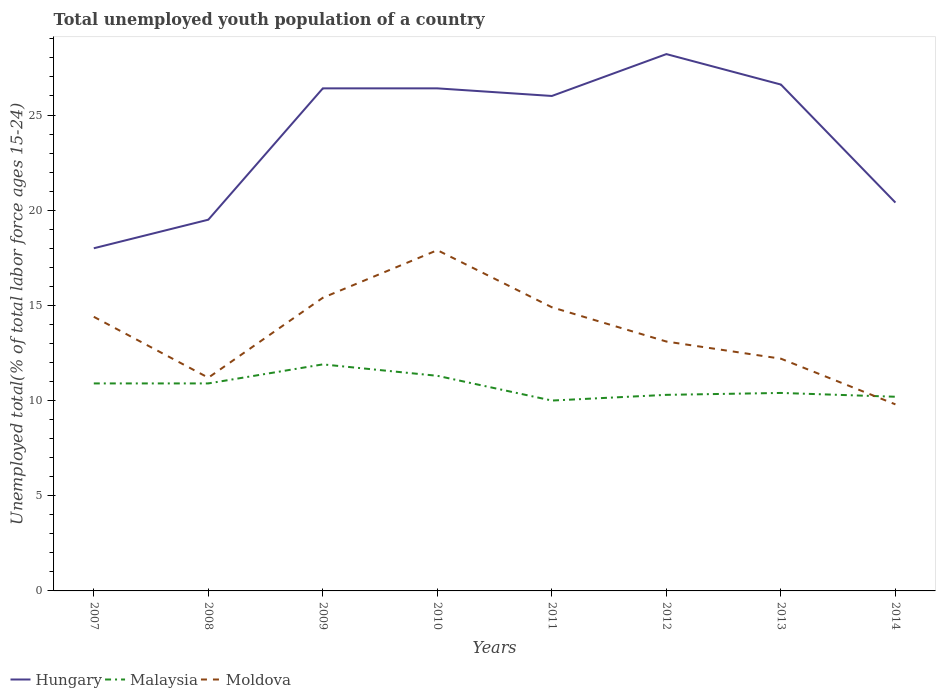Does the line corresponding to Hungary intersect with the line corresponding to Moldova?
Ensure brevity in your answer.  No. Across all years, what is the maximum percentage of total unemployed youth population of a country in Moldova?
Offer a terse response. 9.8. In which year was the percentage of total unemployed youth population of a country in Hungary maximum?
Give a very brief answer. 2007. What is the total percentage of total unemployed youth population of a country in Malaysia in the graph?
Offer a very short reply. 0.1. What is the difference between the highest and the second highest percentage of total unemployed youth population of a country in Moldova?
Offer a very short reply. 8.1. How many lines are there?
Your answer should be compact. 3. Are the values on the major ticks of Y-axis written in scientific E-notation?
Make the answer very short. No. Where does the legend appear in the graph?
Give a very brief answer. Bottom left. How are the legend labels stacked?
Your answer should be very brief. Horizontal. What is the title of the graph?
Provide a succinct answer. Total unemployed youth population of a country. What is the label or title of the Y-axis?
Offer a very short reply. Unemployed total(% of total labor force ages 15-24). What is the Unemployed total(% of total labor force ages 15-24) in Malaysia in 2007?
Offer a very short reply. 10.9. What is the Unemployed total(% of total labor force ages 15-24) in Moldova in 2007?
Provide a short and direct response. 14.4. What is the Unemployed total(% of total labor force ages 15-24) of Malaysia in 2008?
Ensure brevity in your answer.  10.9. What is the Unemployed total(% of total labor force ages 15-24) of Moldova in 2008?
Your response must be concise. 11.2. What is the Unemployed total(% of total labor force ages 15-24) of Hungary in 2009?
Give a very brief answer. 26.4. What is the Unemployed total(% of total labor force ages 15-24) of Malaysia in 2009?
Ensure brevity in your answer.  11.9. What is the Unemployed total(% of total labor force ages 15-24) of Moldova in 2009?
Your answer should be very brief. 15.4. What is the Unemployed total(% of total labor force ages 15-24) of Hungary in 2010?
Provide a short and direct response. 26.4. What is the Unemployed total(% of total labor force ages 15-24) in Malaysia in 2010?
Offer a very short reply. 11.3. What is the Unemployed total(% of total labor force ages 15-24) in Moldova in 2010?
Keep it short and to the point. 17.9. What is the Unemployed total(% of total labor force ages 15-24) of Hungary in 2011?
Keep it short and to the point. 26. What is the Unemployed total(% of total labor force ages 15-24) of Moldova in 2011?
Your response must be concise. 14.9. What is the Unemployed total(% of total labor force ages 15-24) of Hungary in 2012?
Offer a very short reply. 28.2. What is the Unemployed total(% of total labor force ages 15-24) in Malaysia in 2012?
Your response must be concise. 10.3. What is the Unemployed total(% of total labor force ages 15-24) of Moldova in 2012?
Your answer should be very brief. 13.1. What is the Unemployed total(% of total labor force ages 15-24) in Hungary in 2013?
Your answer should be very brief. 26.6. What is the Unemployed total(% of total labor force ages 15-24) in Malaysia in 2013?
Provide a succinct answer. 10.4. What is the Unemployed total(% of total labor force ages 15-24) in Moldova in 2013?
Ensure brevity in your answer.  12.2. What is the Unemployed total(% of total labor force ages 15-24) of Hungary in 2014?
Provide a succinct answer. 20.4. What is the Unemployed total(% of total labor force ages 15-24) in Malaysia in 2014?
Offer a very short reply. 10.2. What is the Unemployed total(% of total labor force ages 15-24) in Moldova in 2014?
Offer a very short reply. 9.8. Across all years, what is the maximum Unemployed total(% of total labor force ages 15-24) in Hungary?
Give a very brief answer. 28.2. Across all years, what is the maximum Unemployed total(% of total labor force ages 15-24) of Malaysia?
Give a very brief answer. 11.9. Across all years, what is the maximum Unemployed total(% of total labor force ages 15-24) of Moldova?
Ensure brevity in your answer.  17.9. Across all years, what is the minimum Unemployed total(% of total labor force ages 15-24) of Moldova?
Your answer should be compact. 9.8. What is the total Unemployed total(% of total labor force ages 15-24) in Hungary in the graph?
Ensure brevity in your answer.  191.5. What is the total Unemployed total(% of total labor force ages 15-24) of Malaysia in the graph?
Keep it short and to the point. 85.9. What is the total Unemployed total(% of total labor force ages 15-24) in Moldova in the graph?
Ensure brevity in your answer.  108.9. What is the difference between the Unemployed total(% of total labor force ages 15-24) of Hungary in 2007 and that in 2008?
Provide a succinct answer. -1.5. What is the difference between the Unemployed total(% of total labor force ages 15-24) in Moldova in 2007 and that in 2008?
Provide a short and direct response. 3.2. What is the difference between the Unemployed total(% of total labor force ages 15-24) of Hungary in 2007 and that in 2009?
Keep it short and to the point. -8.4. What is the difference between the Unemployed total(% of total labor force ages 15-24) of Moldova in 2007 and that in 2010?
Your answer should be compact. -3.5. What is the difference between the Unemployed total(% of total labor force ages 15-24) in Malaysia in 2007 and that in 2011?
Your response must be concise. 0.9. What is the difference between the Unemployed total(% of total labor force ages 15-24) of Hungary in 2007 and that in 2012?
Provide a succinct answer. -10.2. What is the difference between the Unemployed total(% of total labor force ages 15-24) of Moldova in 2007 and that in 2012?
Ensure brevity in your answer.  1.3. What is the difference between the Unemployed total(% of total labor force ages 15-24) of Hungary in 2007 and that in 2013?
Your response must be concise. -8.6. What is the difference between the Unemployed total(% of total labor force ages 15-24) in Malaysia in 2007 and that in 2013?
Your answer should be compact. 0.5. What is the difference between the Unemployed total(% of total labor force ages 15-24) of Malaysia in 2008 and that in 2009?
Provide a succinct answer. -1. What is the difference between the Unemployed total(% of total labor force ages 15-24) of Malaysia in 2008 and that in 2010?
Ensure brevity in your answer.  -0.4. What is the difference between the Unemployed total(% of total labor force ages 15-24) in Moldova in 2008 and that in 2010?
Offer a terse response. -6.7. What is the difference between the Unemployed total(% of total labor force ages 15-24) of Malaysia in 2008 and that in 2011?
Provide a short and direct response. 0.9. What is the difference between the Unemployed total(% of total labor force ages 15-24) of Malaysia in 2008 and that in 2012?
Your answer should be compact. 0.6. What is the difference between the Unemployed total(% of total labor force ages 15-24) of Moldova in 2008 and that in 2012?
Offer a terse response. -1.9. What is the difference between the Unemployed total(% of total labor force ages 15-24) of Hungary in 2008 and that in 2013?
Provide a short and direct response. -7.1. What is the difference between the Unemployed total(% of total labor force ages 15-24) of Malaysia in 2008 and that in 2013?
Provide a short and direct response. 0.5. What is the difference between the Unemployed total(% of total labor force ages 15-24) in Malaysia in 2008 and that in 2014?
Give a very brief answer. 0.7. What is the difference between the Unemployed total(% of total labor force ages 15-24) in Hungary in 2009 and that in 2011?
Keep it short and to the point. 0.4. What is the difference between the Unemployed total(% of total labor force ages 15-24) of Moldova in 2009 and that in 2011?
Give a very brief answer. 0.5. What is the difference between the Unemployed total(% of total labor force ages 15-24) in Hungary in 2009 and that in 2013?
Offer a very short reply. -0.2. What is the difference between the Unemployed total(% of total labor force ages 15-24) of Moldova in 2009 and that in 2013?
Keep it short and to the point. 3.2. What is the difference between the Unemployed total(% of total labor force ages 15-24) in Malaysia in 2010 and that in 2011?
Your answer should be compact. 1.3. What is the difference between the Unemployed total(% of total labor force ages 15-24) in Moldova in 2010 and that in 2011?
Offer a terse response. 3. What is the difference between the Unemployed total(% of total labor force ages 15-24) in Malaysia in 2010 and that in 2012?
Offer a terse response. 1. What is the difference between the Unemployed total(% of total labor force ages 15-24) of Moldova in 2010 and that in 2013?
Give a very brief answer. 5.7. What is the difference between the Unemployed total(% of total labor force ages 15-24) of Moldova in 2010 and that in 2014?
Keep it short and to the point. 8.1. What is the difference between the Unemployed total(% of total labor force ages 15-24) in Malaysia in 2011 and that in 2012?
Offer a very short reply. -0.3. What is the difference between the Unemployed total(% of total labor force ages 15-24) of Moldova in 2011 and that in 2012?
Your answer should be compact. 1.8. What is the difference between the Unemployed total(% of total labor force ages 15-24) in Hungary in 2011 and that in 2014?
Give a very brief answer. 5.6. What is the difference between the Unemployed total(% of total labor force ages 15-24) in Malaysia in 2011 and that in 2014?
Your response must be concise. -0.2. What is the difference between the Unemployed total(% of total labor force ages 15-24) of Moldova in 2011 and that in 2014?
Make the answer very short. 5.1. What is the difference between the Unemployed total(% of total labor force ages 15-24) of Malaysia in 2012 and that in 2013?
Your response must be concise. -0.1. What is the difference between the Unemployed total(% of total labor force ages 15-24) of Moldova in 2012 and that in 2013?
Provide a short and direct response. 0.9. What is the difference between the Unemployed total(% of total labor force ages 15-24) of Malaysia in 2012 and that in 2014?
Your answer should be very brief. 0.1. What is the difference between the Unemployed total(% of total labor force ages 15-24) in Moldova in 2012 and that in 2014?
Give a very brief answer. 3.3. What is the difference between the Unemployed total(% of total labor force ages 15-24) of Moldova in 2013 and that in 2014?
Provide a succinct answer. 2.4. What is the difference between the Unemployed total(% of total labor force ages 15-24) in Hungary in 2007 and the Unemployed total(% of total labor force ages 15-24) in Moldova in 2008?
Offer a terse response. 6.8. What is the difference between the Unemployed total(% of total labor force ages 15-24) of Hungary in 2007 and the Unemployed total(% of total labor force ages 15-24) of Moldova in 2009?
Offer a terse response. 2.6. What is the difference between the Unemployed total(% of total labor force ages 15-24) of Hungary in 2007 and the Unemployed total(% of total labor force ages 15-24) of Malaysia in 2010?
Your answer should be very brief. 6.7. What is the difference between the Unemployed total(% of total labor force ages 15-24) in Malaysia in 2007 and the Unemployed total(% of total labor force ages 15-24) in Moldova in 2010?
Your answer should be very brief. -7. What is the difference between the Unemployed total(% of total labor force ages 15-24) in Hungary in 2007 and the Unemployed total(% of total labor force ages 15-24) in Malaysia in 2013?
Give a very brief answer. 7.6. What is the difference between the Unemployed total(% of total labor force ages 15-24) in Hungary in 2007 and the Unemployed total(% of total labor force ages 15-24) in Moldova in 2013?
Your response must be concise. 5.8. What is the difference between the Unemployed total(% of total labor force ages 15-24) of Malaysia in 2007 and the Unemployed total(% of total labor force ages 15-24) of Moldova in 2013?
Keep it short and to the point. -1.3. What is the difference between the Unemployed total(% of total labor force ages 15-24) of Hungary in 2008 and the Unemployed total(% of total labor force ages 15-24) of Malaysia in 2009?
Provide a succinct answer. 7.6. What is the difference between the Unemployed total(% of total labor force ages 15-24) in Malaysia in 2008 and the Unemployed total(% of total labor force ages 15-24) in Moldova in 2009?
Make the answer very short. -4.5. What is the difference between the Unemployed total(% of total labor force ages 15-24) in Hungary in 2008 and the Unemployed total(% of total labor force ages 15-24) in Malaysia in 2010?
Provide a succinct answer. 8.2. What is the difference between the Unemployed total(% of total labor force ages 15-24) of Hungary in 2008 and the Unemployed total(% of total labor force ages 15-24) of Malaysia in 2011?
Your answer should be very brief. 9.5. What is the difference between the Unemployed total(% of total labor force ages 15-24) in Malaysia in 2008 and the Unemployed total(% of total labor force ages 15-24) in Moldova in 2011?
Offer a very short reply. -4. What is the difference between the Unemployed total(% of total labor force ages 15-24) of Hungary in 2008 and the Unemployed total(% of total labor force ages 15-24) of Moldova in 2012?
Provide a short and direct response. 6.4. What is the difference between the Unemployed total(% of total labor force ages 15-24) in Malaysia in 2008 and the Unemployed total(% of total labor force ages 15-24) in Moldova in 2012?
Ensure brevity in your answer.  -2.2. What is the difference between the Unemployed total(% of total labor force ages 15-24) of Hungary in 2008 and the Unemployed total(% of total labor force ages 15-24) of Malaysia in 2014?
Provide a short and direct response. 9.3. What is the difference between the Unemployed total(% of total labor force ages 15-24) in Malaysia in 2009 and the Unemployed total(% of total labor force ages 15-24) in Moldova in 2010?
Provide a short and direct response. -6. What is the difference between the Unemployed total(% of total labor force ages 15-24) in Malaysia in 2009 and the Unemployed total(% of total labor force ages 15-24) in Moldova in 2011?
Give a very brief answer. -3. What is the difference between the Unemployed total(% of total labor force ages 15-24) in Hungary in 2009 and the Unemployed total(% of total labor force ages 15-24) in Malaysia in 2012?
Keep it short and to the point. 16.1. What is the difference between the Unemployed total(% of total labor force ages 15-24) of Hungary in 2009 and the Unemployed total(% of total labor force ages 15-24) of Moldova in 2012?
Offer a terse response. 13.3. What is the difference between the Unemployed total(% of total labor force ages 15-24) in Malaysia in 2009 and the Unemployed total(% of total labor force ages 15-24) in Moldova in 2012?
Provide a short and direct response. -1.2. What is the difference between the Unemployed total(% of total labor force ages 15-24) in Hungary in 2009 and the Unemployed total(% of total labor force ages 15-24) in Malaysia in 2013?
Keep it short and to the point. 16. What is the difference between the Unemployed total(% of total labor force ages 15-24) in Hungary in 2009 and the Unemployed total(% of total labor force ages 15-24) in Moldova in 2013?
Keep it short and to the point. 14.2. What is the difference between the Unemployed total(% of total labor force ages 15-24) in Hungary in 2010 and the Unemployed total(% of total labor force ages 15-24) in Malaysia in 2012?
Offer a terse response. 16.1. What is the difference between the Unemployed total(% of total labor force ages 15-24) of Malaysia in 2010 and the Unemployed total(% of total labor force ages 15-24) of Moldova in 2012?
Provide a succinct answer. -1.8. What is the difference between the Unemployed total(% of total labor force ages 15-24) of Hungary in 2010 and the Unemployed total(% of total labor force ages 15-24) of Moldova in 2013?
Make the answer very short. 14.2. What is the difference between the Unemployed total(% of total labor force ages 15-24) in Malaysia in 2010 and the Unemployed total(% of total labor force ages 15-24) in Moldova in 2013?
Your answer should be very brief. -0.9. What is the difference between the Unemployed total(% of total labor force ages 15-24) in Hungary in 2010 and the Unemployed total(% of total labor force ages 15-24) in Moldova in 2014?
Provide a short and direct response. 16.6. What is the difference between the Unemployed total(% of total labor force ages 15-24) of Malaysia in 2010 and the Unemployed total(% of total labor force ages 15-24) of Moldova in 2014?
Your answer should be very brief. 1.5. What is the difference between the Unemployed total(% of total labor force ages 15-24) in Hungary in 2011 and the Unemployed total(% of total labor force ages 15-24) in Malaysia in 2012?
Your answer should be compact. 15.7. What is the difference between the Unemployed total(% of total labor force ages 15-24) of Hungary in 2011 and the Unemployed total(% of total labor force ages 15-24) of Moldova in 2012?
Your answer should be very brief. 12.9. What is the difference between the Unemployed total(% of total labor force ages 15-24) in Malaysia in 2011 and the Unemployed total(% of total labor force ages 15-24) in Moldova in 2012?
Provide a short and direct response. -3.1. What is the difference between the Unemployed total(% of total labor force ages 15-24) in Hungary in 2011 and the Unemployed total(% of total labor force ages 15-24) in Malaysia in 2013?
Provide a succinct answer. 15.6. What is the difference between the Unemployed total(% of total labor force ages 15-24) of Hungary in 2011 and the Unemployed total(% of total labor force ages 15-24) of Moldova in 2013?
Provide a succinct answer. 13.8. What is the difference between the Unemployed total(% of total labor force ages 15-24) of Hungary in 2011 and the Unemployed total(% of total labor force ages 15-24) of Malaysia in 2014?
Make the answer very short. 15.8. What is the difference between the Unemployed total(% of total labor force ages 15-24) in Hungary in 2011 and the Unemployed total(% of total labor force ages 15-24) in Moldova in 2014?
Keep it short and to the point. 16.2. What is the difference between the Unemployed total(% of total labor force ages 15-24) in Malaysia in 2012 and the Unemployed total(% of total labor force ages 15-24) in Moldova in 2013?
Your answer should be very brief. -1.9. What is the difference between the Unemployed total(% of total labor force ages 15-24) in Hungary in 2012 and the Unemployed total(% of total labor force ages 15-24) in Malaysia in 2014?
Provide a succinct answer. 18. What is the difference between the Unemployed total(% of total labor force ages 15-24) of Hungary in 2013 and the Unemployed total(% of total labor force ages 15-24) of Malaysia in 2014?
Make the answer very short. 16.4. What is the difference between the Unemployed total(% of total labor force ages 15-24) in Malaysia in 2013 and the Unemployed total(% of total labor force ages 15-24) in Moldova in 2014?
Provide a short and direct response. 0.6. What is the average Unemployed total(% of total labor force ages 15-24) in Hungary per year?
Your response must be concise. 23.94. What is the average Unemployed total(% of total labor force ages 15-24) of Malaysia per year?
Your answer should be very brief. 10.74. What is the average Unemployed total(% of total labor force ages 15-24) in Moldova per year?
Keep it short and to the point. 13.61. In the year 2007, what is the difference between the Unemployed total(% of total labor force ages 15-24) in Hungary and Unemployed total(% of total labor force ages 15-24) in Malaysia?
Offer a very short reply. 7.1. In the year 2008, what is the difference between the Unemployed total(% of total labor force ages 15-24) in Hungary and Unemployed total(% of total labor force ages 15-24) in Moldova?
Your response must be concise. 8.3. In the year 2009, what is the difference between the Unemployed total(% of total labor force ages 15-24) in Hungary and Unemployed total(% of total labor force ages 15-24) in Moldova?
Your answer should be compact. 11. In the year 2009, what is the difference between the Unemployed total(% of total labor force ages 15-24) in Malaysia and Unemployed total(% of total labor force ages 15-24) in Moldova?
Make the answer very short. -3.5. In the year 2010, what is the difference between the Unemployed total(% of total labor force ages 15-24) in Hungary and Unemployed total(% of total labor force ages 15-24) in Malaysia?
Keep it short and to the point. 15.1. In the year 2010, what is the difference between the Unemployed total(% of total labor force ages 15-24) in Hungary and Unemployed total(% of total labor force ages 15-24) in Moldova?
Your answer should be compact. 8.5. In the year 2010, what is the difference between the Unemployed total(% of total labor force ages 15-24) in Malaysia and Unemployed total(% of total labor force ages 15-24) in Moldova?
Keep it short and to the point. -6.6. In the year 2011, what is the difference between the Unemployed total(% of total labor force ages 15-24) in Hungary and Unemployed total(% of total labor force ages 15-24) in Malaysia?
Offer a terse response. 16. In the year 2011, what is the difference between the Unemployed total(% of total labor force ages 15-24) of Malaysia and Unemployed total(% of total labor force ages 15-24) of Moldova?
Ensure brevity in your answer.  -4.9. In the year 2012, what is the difference between the Unemployed total(% of total labor force ages 15-24) of Malaysia and Unemployed total(% of total labor force ages 15-24) of Moldova?
Give a very brief answer. -2.8. In the year 2013, what is the difference between the Unemployed total(% of total labor force ages 15-24) in Hungary and Unemployed total(% of total labor force ages 15-24) in Malaysia?
Your answer should be very brief. 16.2. In the year 2013, what is the difference between the Unemployed total(% of total labor force ages 15-24) in Malaysia and Unemployed total(% of total labor force ages 15-24) in Moldova?
Keep it short and to the point. -1.8. In the year 2014, what is the difference between the Unemployed total(% of total labor force ages 15-24) of Hungary and Unemployed total(% of total labor force ages 15-24) of Moldova?
Your response must be concise. 10.6. In the year 2014, what is the difference between the Unemployed total(% of total labor force ages 15-24) of Malaysia and Unemployed total(% of total labor force ages 15-24) of Moldova?
Keep it short and to the point. 0.4. What is the ratio of the Unemployed total(% of total labor force ages 15-24) in Moldova in 2007 to that in 2008?
Your answer should be very brief. 1.29. What is the ratio of the Unemployed total(% of total labor force ages 15-24) in Hungary in 2007 to that in 2009?
Your answer should be compact. 0.68. What is the ratio of the Unemployed total(% of total labor force ages 15-24) in Malaysia in 2007 to that in 2009?
Your answer should be very brief. 0.92. What is the ratio of the Unemployed total(% of total labor force ages 15-24) of Moldova in 2007 to that in 2009?
Make the answer very short. 0.94. What is the ratio of the Unemployed total(% of total labor force ages 15-24) of Hungary in 2007 to that in 2010?
Offer a terse response. 0.68. What is the ratio of the Unemployed total(% of total labor force ages 15-24) in Malaysia in 2007 to that in 2010?
Make the answer very short. 0.96. What is the ratio of the Unemployed total(% of total labor force ages 15-24) in Moldova in 2007 to that in 2010?
Provide a succinct answer. 0.8. What is the ratio of the Unemployed total(% of total labor force ages 15-24) of Hungary in 2007 to that in 2011?
Your answer should be compact. 0.69. What is the ratio of the Unemployed total(% of total labor force ages 15-24) of Malaysia in 2007 to that in 2011?
Keep it short and to the point. 1.09. What is the ratio of the Unemployed total(% of total labor force ages 15-24) of Moldova in 2007 to that in 2011?
Keep it short and to the point. 0.97. What is the ratio of the Unemployed total(% of total labor force ages 15-24) of Hungary in 2007 to that in 2012?
Ensure brevity in your answer.  0.64. What is the ratio of the Unemployed total(% of total labor force ages 15-24) of Malaysia in 2007 to that in 2012?
Your answer should be compact. 1.06. What is the ratio of the Unemployed total(% of total labor force ages 15-24) in Moldova in 2007 to that in 2012?
Offer a very short reply. 1.1. What is the ratio of the Unemployed total(% of total labor force ages 15-24) in Hungary in 2007 to that in 2013?
Make the answer very short. 0.68. What is the ratio of the Unemployed total(% of total labor force ages 15-24) in Malaysia in 2007 to that in 2013?
Offer a terse response. 1.05. What is the ratio of the Unemployed total(% of total labor force ages 15-24) in Moldova in 2007 to that in 2013?
Provide a short and direct response. 1.18. What is the ratio of the Unemployed total(% of total labor force ages 15-24) of Hungary in 2007 to that in 2014?
Ensure brevity in your answer.  0.88. What is the ratio of the Unemployed total(% of total labor force ages 15-24) in Malaysia in 2007 to that in 2014?
Give a very brief answer. 1.07. What is the ratio of the Unemployed total(% of total labor force ages 15-24) in Moldova in 2007 to that in 2014?
Provide a short and direct response. 1.47. What is the ratio of the Unemployed total(% of total labor force ages 15-24) in Hungary in 2008 to that in 2009?
Provide a short and direct response. 0.74. What is the ratio of the Unemployed total(% of total labor force ages 15-24) of Malaysia in 2008 to that in 2009?
Your response must be concise. 0.92. What is the ratio of the Unemployed total(% of total labor force ages 15-24) of Moldova in 2008 to that in 2009?
Your answer should be very brief. 0.73. What is the ratio of the Unemployed total(% of total labor force ages 15-24) in Hungary in 2008 to that in 2010?
Your answer should be very brief. 0.74. What is the ratio of the Unemployed total(% of total labor force ages 15-24) in Malaysia in 2008 to that in 2010?
Provide a short and direct response. 0.96. What is the ratio of the Unemployed total(% of total labor force ages 15-24) in Moldova in 2008 to that in 2010?
Your answer should be compact. 0.63. What is the ratio of the Unemployed total(% of total labor force ages 15-24) of Malaysia in 2008 to that in 2011?
Provide a succinct answer. 1.09. What is the ratio of the Unemployed total(% of total labor force ages 15-24) of Moldova in 2008 to that in 2011?
Keep it short and to the point. 0.75. What is the ratio of the Unemployed total(% of total labor force ages 15-24) in Hungary in 2008 to that in 2012?
Offer a terse response. 0.69. What is the ratio of the Unemployed total(% of total labor force ages 15-24) of Malaysia in 2008 to that in 2012?
Keep it short and to the point. 1.06. What is the ratio of the Unemployed total(% of total labor force ages 15-24) of Moldova in 2008 to that in 2012?
Your answer should be compact. 0.85. What is the ratio of the Unemployed total(% of total labor force ages 15-24) in Hungary in 2008 to that in 2013?
Provide a succinct answer. 0.73. What is the ratio of the Unemployed total(% of total labor force ages 15-24) in Malaysia in 2008 to that in 2013?
Provide a short and direct response. 1.05. What is the ratio of the Unemployed total(% of total labor force ages 15-24) in Moldova in 2008 to that in 2013?
Make the answer very short. 0.92. What is the ratio of the Unemployed total(% of total labor force ages 15-24) in Hungary in 2008 to that in 2014?
Offer a terse response. 0.96. What is the ratio of the Unemployed total(% of total labor force ages 15-24) in Malaysia in 2008 to that in 2014?
Your answer should be very brief. 1.07. What is the ratio of the Unemployed total(% of total labor force ages 15-24) of Moldova in 2008 to that in 2014?
Ensure brevity in your answer.  1.14. What is the ratio of the Unemployed total(% of total labor force ages 15-24) of Malaysia in 2009 to that in 2010?
Keep it short and to the point. 1.05. What is the ratio of the Unemployed total(% of total labor force ages 15-24) of Moldova in 2009 to that in 2010?
Provide a succinct answer. 0.86. What is the ratio of the Unemployed total(% of total labor force ages 15-24) of Hungary in 2009 to that in 2011?
Provide a succinct answer. 1.02. What is the ratio of the Unemployed total(% of total labor force ages 15-24) of Malaysia in 2009 to that in 2011?
Keep it short and to the point. 1.19. What is the ratio of the Unemployed total(% of total labor force ages 15-24) of Moldova in 2009 to that in 2011?
Offer a terse response. 1.03. What is the ratio of the Unemployed total(% of total labor force ages 15-24) of Hungary in 2009 to that in 2012?
Provide a succinct answer. 0.94. What is the ratio of the Unemployed total(% of total labor force ages 15-24) of Malaysia in 2009 to that in 2012?
Offer a terse response. 1.16. What is the ratio of the Unemployed total(% of total labor force ages 15-24) of Moldova in 2009 to that in 2012?
Keep it short and to the point. 1.18. What is the ratio of the Unemployed total(% of total labor force ages 15-24) in Hungary in 2009 to that in 2013?
Your answer should be very brief. 0.99. What is the ratio of the Unemployed total(% of total labor force ages 15-24) of Malaysia in 2009 to that in 2013?
Offer a terse response. 1.14. What is the ratio of the Unemployed total(% of total labor force ages 15-24) in Moldova in 2009 to that in 2013?
Ensure brevity in your answer.  1.26. What is the ratio of the Unemployed total(% of total labor force ages 15-24) of Hungary in 2009 to that in 2014?
Provide a succinct answer. 1.29. What is the ratio of the Unemployed total(% of total labor force ages 15-24) of Malaysia in 2009 to that in 2014?
Keep it short and to the point. 1.17. What is the ratio of the Unemployed total(% of total labor force ages 15-24) of Moldova in 2009 to that in 2014?
Offer a terse response. 1.57. What is the ratio of the Unemployed total(% of total labor force ages 15-24) of Hungary in 2010 to that in 2011?
Make the answer very short. 1.02. What is the ratio of the Unemployed total(% of total labor force ages 15-24) in Malaysia in 2010 to that in 2011?
Make the answer very short. 1.13. What is the ratio of the Unemployed total(% of total labor force ages 15-24) in Moldova in 2010 to that in 2011?
Ensure brevity in your answer.  1.2. What is the ratio of the Unemployed total(% of total labor force ages 15-24) of Hungary in 2010 to that in 2012?
Make the answer very short. 0.94. What is the ratio of the Unemployed total(% of total labor force ages 15-24) of Malaysia in 2010 to that in 2012?
Keep it short and to the point. 1.1. What is the ratio of the Unemployed total(% of total labor force ages 15-24) in Moldova in 2010 to that in 2012?
Offer a very short reply. 1.37. What is the ratio of the Unemployed total(% of total labor force ages 15-24) in Malaysia in 2010 to that in 2013?
Keep it short and to the point. 1.09. What is the ratio of the Unemployed total(% of total labor force ages 15-24) of Moldova in 2010 to that in 2013?
Provide a succinct answer. 1.47. What is the ratio of the Unemployed total(% of total labor force ages 15-24) in Hungary in 2010 to that in 2014?
Offer a terse response. 1.29. What is the ratio of the Unemployed total(% of total labor force ages 15-24) of Malaysia in 2010 to that in 2014?
Keep it short and to the point. 1.11. What is the ratio of the Unemployed total(% of total labor force ages 15-24) in Moldova in 2010 to that in 2014?
Keep it short and to the point. 1.83. What is the ratio of the Unemployed total(% of total labor force ages 15-24) in Hungary in 2011 to that in 2012?
Offer a terse response. 0.92. What is the ratio of the Unemployed total(% of total labor force ages 15-24) of Malaysia in 2011 to that in 2012?
Your response must be concise. 0.97. What is the ratio of the Unemployed total(% of total labor force ages 15-24) of Moldova in 2011 to that in 2012?
Your answer should be very brief. 1.14. What is the ratio of the Unemployed total(% of total labor force ages 15-24) in Hungary in 2011 to that in 2013?
Provide a short and direct response. 0.98. What is the ratio of the Unemployed total(% of total labor force ages 15-24) of Malaysia in 2011 to that in 2013?
Your response must be concise. 0.96. What is the ratio of the Unemployed total(% of total labor force ages 15-24) in Moldova in 2011 to that in 2013?
Offer a terse response. 1.22. What is the ratio of the Unemployed total(% of total labor force ages 15-24) of Hungary in 2011 to that in 2014?
Make the answer very short. 1.27. What is the ratio of the Unemployed total(% of total labor force ages 15-24) in Malaysia in 2011 to that in 2014?
Ensure brevity in your answer.  0.98. What is the ratio of the Unemployed total(% of total labor force ages 15-24) in Moldova in 2011 to that in 2014?
Offer a terse response. 1.52. What is the ratio of the Unemployed total(% of total labor force ages 15-24) in Hungary in 2012 to that in 2013?
Give a very brief answer. 1.06. What is the ratio of the Unemployed total(% of total labor force ages 15-24) of Moldova in 2012 to that in 2013?
Ensure brevity in your answer.  1.07. What is the ratio of the Unemployed total(% of total labor force ages 15-24) of Hungary in 2012 to that in 2014?
Give a very brief answer. 1.38. What is the ratio of the Unemployed total(% of total labor force ages 15-24) in Malaysia in 2012 to that in 2014?
Give a very brief answer. 1.01. What is the ratio of the Unemployed total(% of total labor force ages 15-24) of Moldova in 2012 to that in 2014?
Your response must be concise. 1.34. What is the ratio of the Unemployed total(% of total labor force ages 15-24) of Hungary in 2013 to that in 2014?
Ensure brevity in your answer.  1.3. What is the ratio of the Unemployed total(% of total labor force ages 15-24) in Malaysia in 2013 to that in 2014?
Provide a succinct answer. 1.02. What is the ratio of the Unemployed total(% of total labor force ages 15-24) in Moldova in 2013 to that in 2014?
Make the answer very short. 1.24. What is the difference between the highest and the second highest Unemployed total(% of total labor force ages 15-24) in Hungary?
Give a very brief answer. 1.6. What is the difference between the highest and the second highest Unemployed total(% of total labor force ages 15-24) in Malaysia?
Your response must be concise. 0.6. What is the difference between the highest and the second highest Unemployed total(% of total labor force ages 15-24) in Moldova?
Your response must be concise. 2.5. 